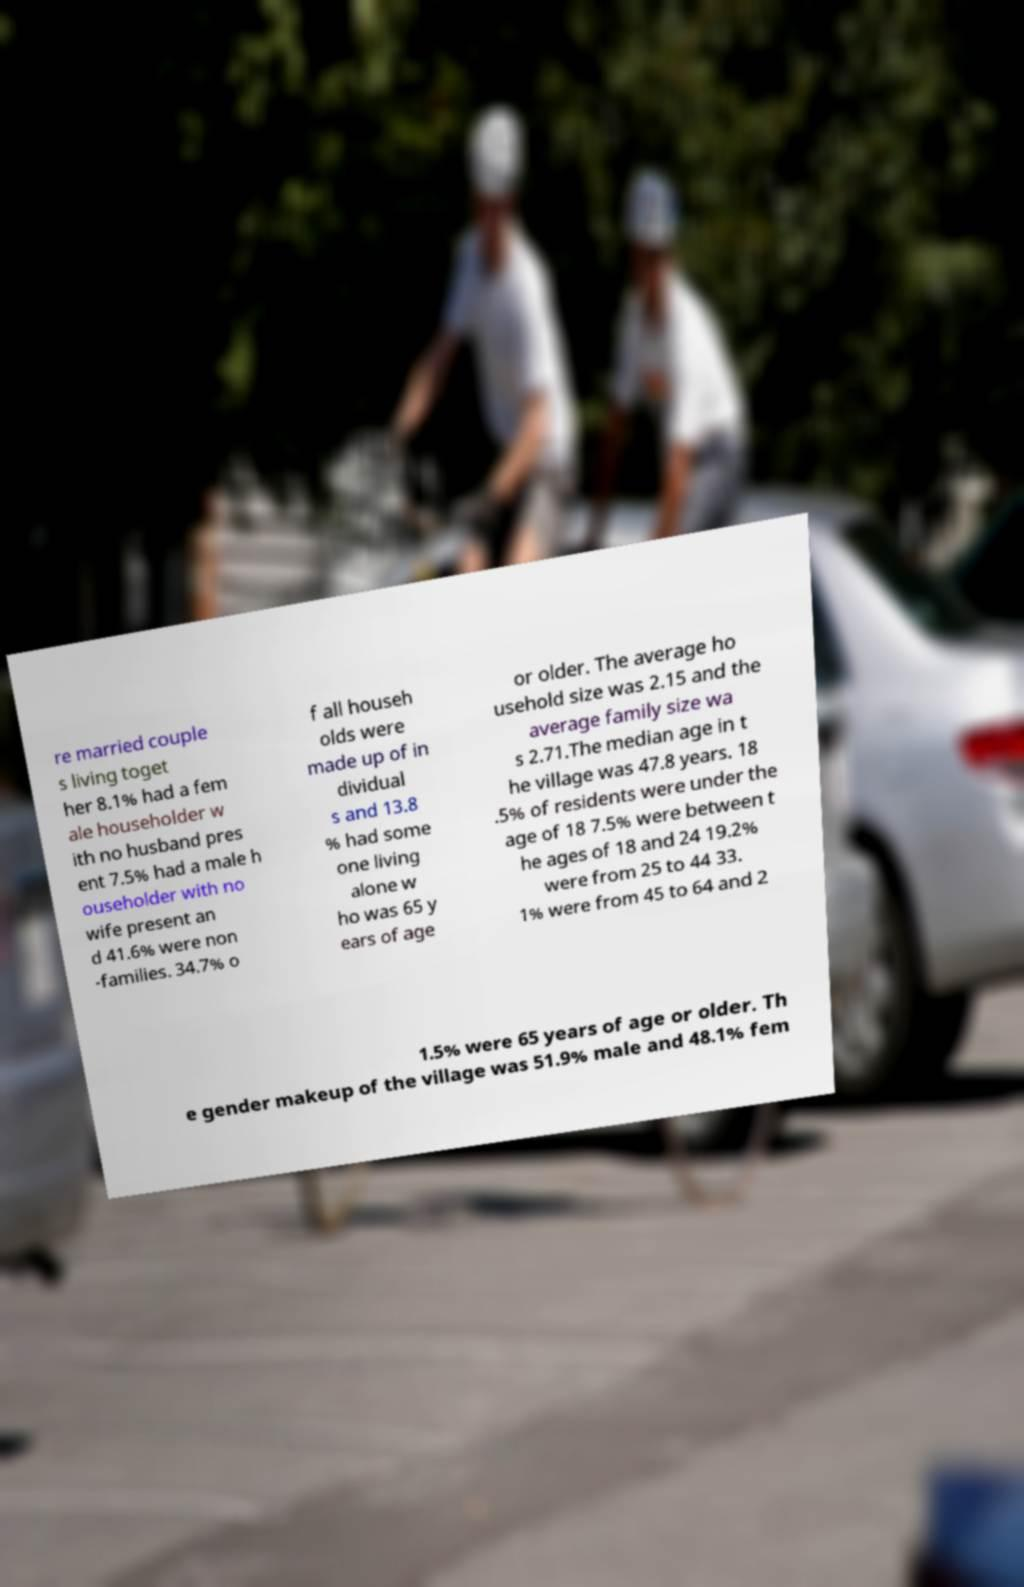I need the written content from this picture converted into text. Can you do that? re married couple s living toget her 8.1% had a fem ale householder w ith no husband pres ent 7.5% had a male h ouseholder with no wife present an d 41.6% were non -families. 34.7% o f all househ olds were made up of in dividual s and 13.8 % had some one living alone w ho was 65 y ears of age or older. The average ho usehold size was 2.15 and the average family size wa s 2.71.The median age in t he village was 47.8 years. 18 .5% of residents were under the age of 18 7.5% were between t he ages of 18 and 24 19.2% were from 25 to 44 33. 1% were from 45 to 64 and 2 1.5% were 65 years of age or older. Th e gender makeup of the village was 51.9% male and 48.1% fem 